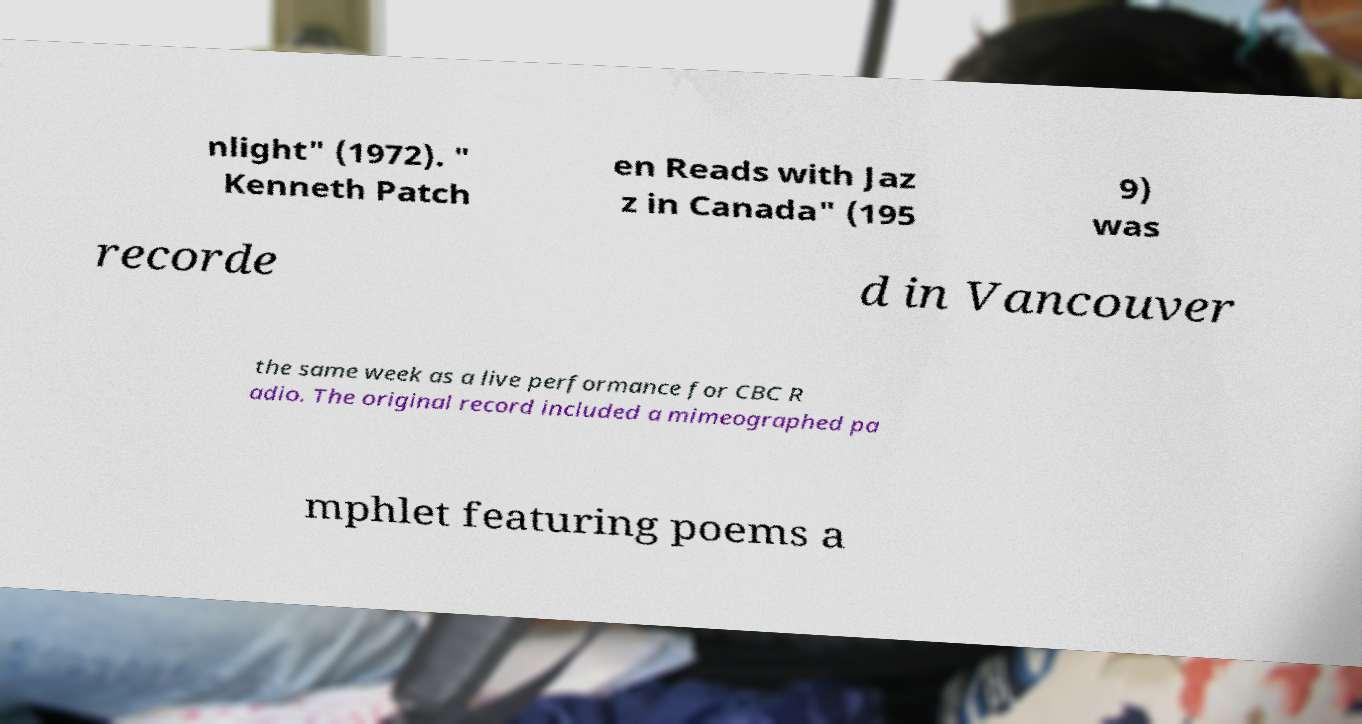I need the written content from this picture converted into text. Can you do that? nlight" (1972). " Kenneth Patch en Reads with Jaz z in Canada" (195 9) was recorde d in Vancouver the same week as a live performance for CBC R adio. The original record included a mimeographed pa mphlet featuring poems a 